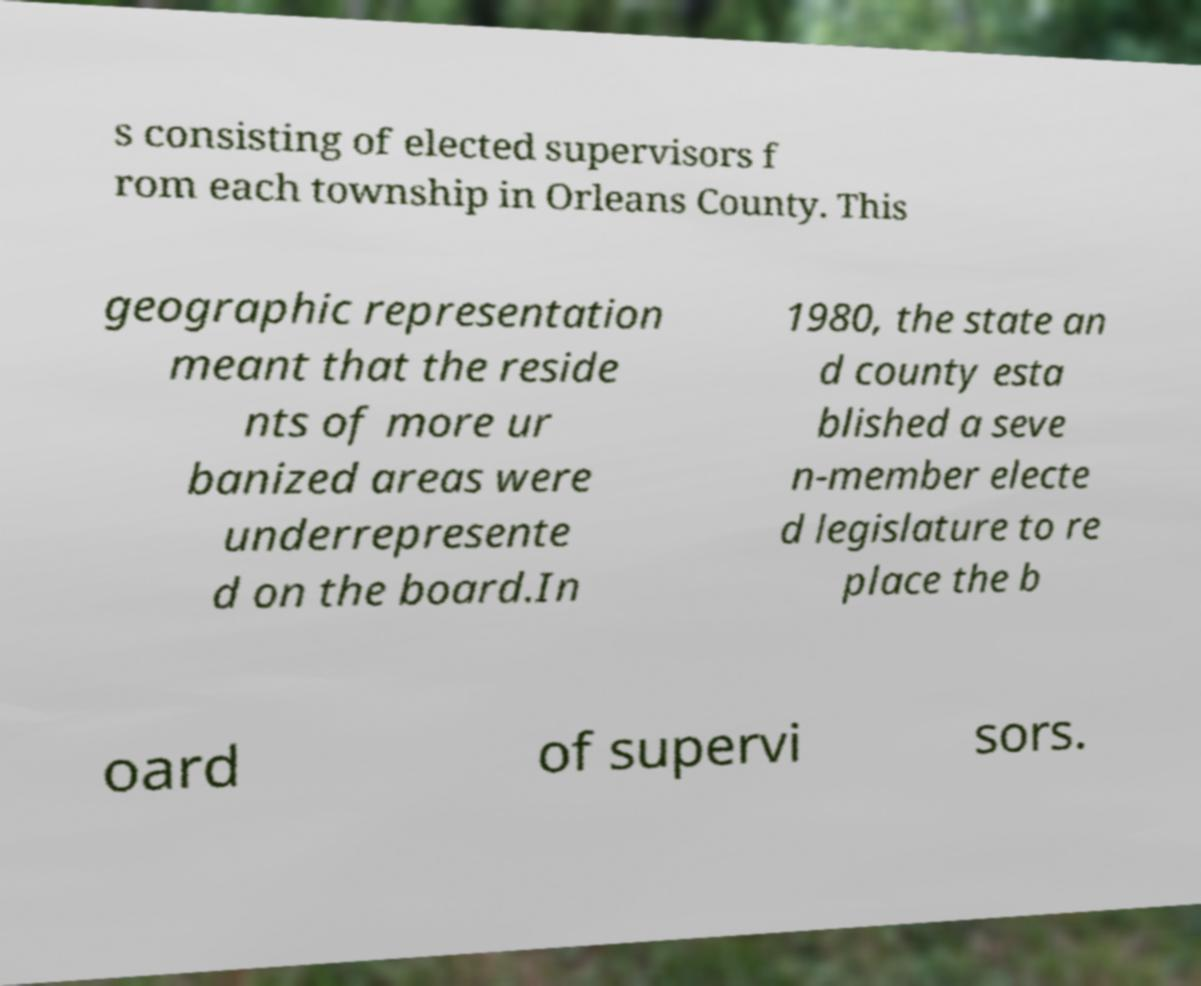Please identify and transcribe the text found in this image. s consisting of elected supervisors f rom each township in Orleans County. This geographic representation meant that the reside nts of more ur banized areas were underrepresente d on the board.In 1980, the state an d county esta blished a seve n-member electe d legislature to re place the b oard of supervi sors. 